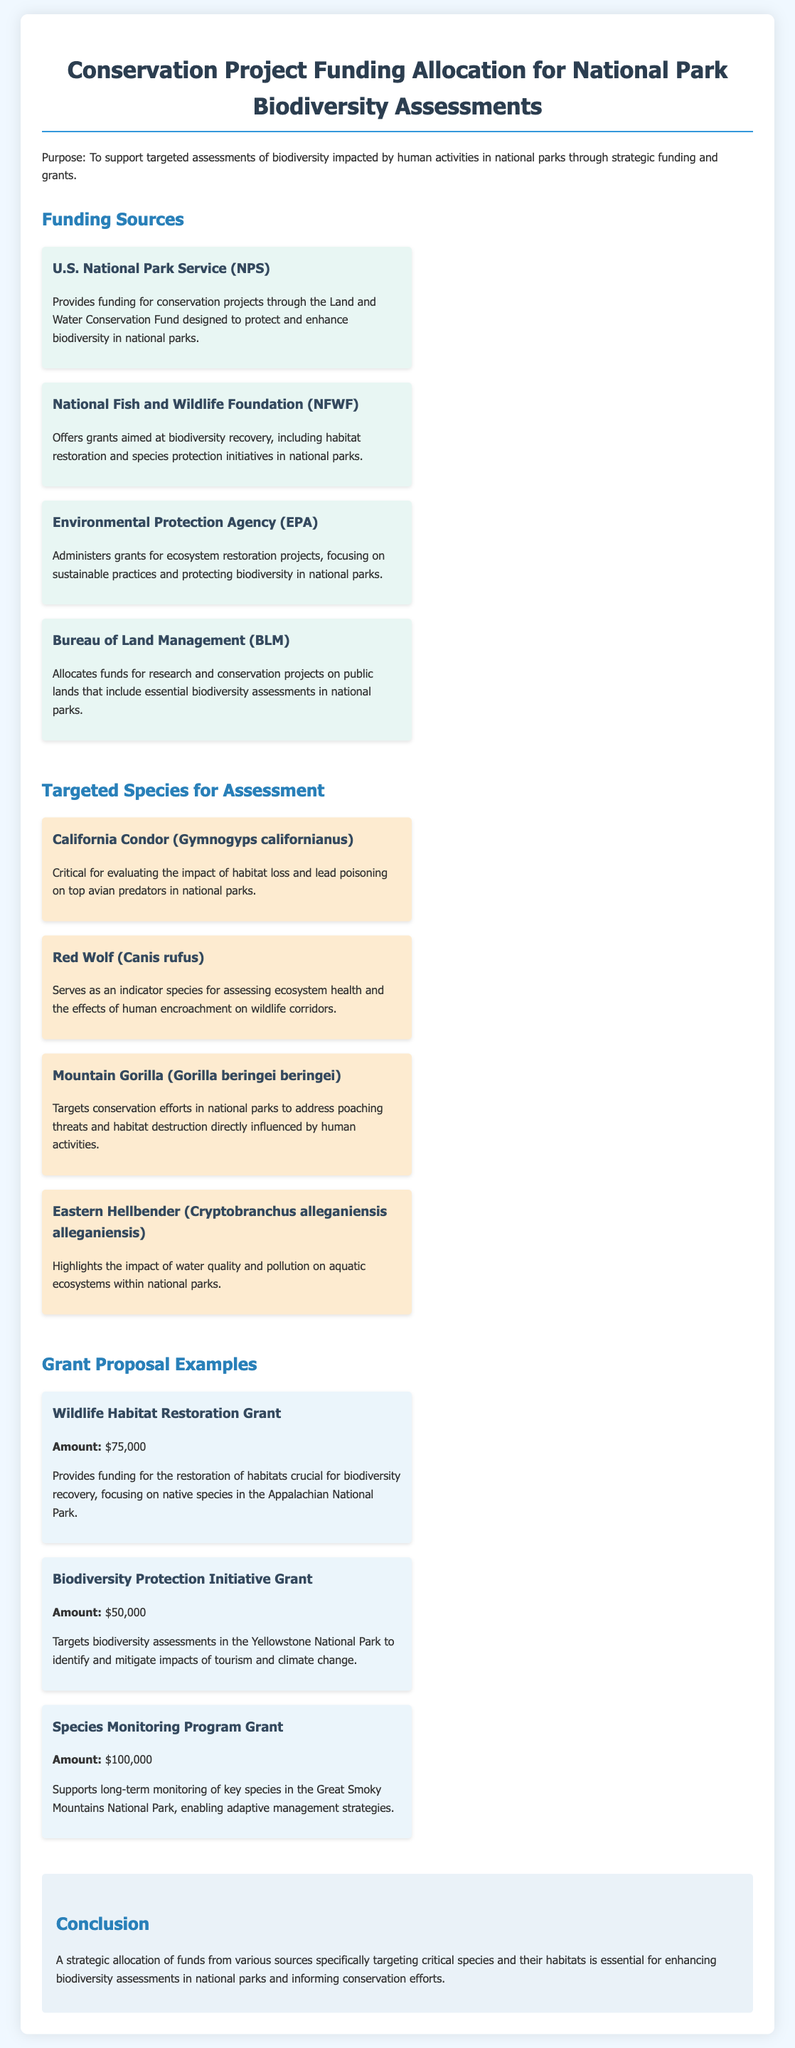What is the purpose of the document? The document outlines the support for targeted assessments of biodiversity impacted by human activities in national parks through strategic funding and grants.
Answer: To support targeted assessments of biodiversity impacted by human activities in national parks through strategic funding and grants What funding source offers grants aimed at biodiversity recovery? The document specifies that the National Fish and Wildlife Foundation offers grants focused on biodiversity recovery initiatives.
Answer: National Fish and Wildlife Foundation How much is the Wildlife Habitat Restoration Grant? The document states that the amount for the Wildlife Habitat Restoration Grant is $75,000.
Answer: $75,000 Which species serves as an indicator for assessing ecosystem health? The Red Wolf is identified in the document as an indicator species for assessing ecosystem health and the effects of human encroachment on wildlife corridors.
Answer: Red Wolf What is one of the targeting species highlighted for its response to water quality? The Eastern Hellbender is mentioned in the document as a species that highlights the impact of water quality and pollution on aquatic ecosystems.
Answer: Eastern Hellbender What is the total funding amount for the Species Monitoring Program Grant? The document mentions that the Species Monitoring Program Grant provides a total of $100,000 for monitoring key species.
Answer: $100,000 How does the Bureau of Land Management contribute to conservation projects? The Bureau of Land Management allocates funds for research and conservation projects on public lands, including biodiversity assessments in national parks.
Answer: Allocates funds for research and conservation projects What conclusion is drawn regarding the allocation of funds? The conclusion emphasizes the necessity of strategic allocation of funds from various sources targeting critical species and their habitats.
Answer: A strategic allocation of funds from various sources specifically targeting critical species and their habitats is essential for enhancing biodiversity assessments in national parks and informing conservation efforts 